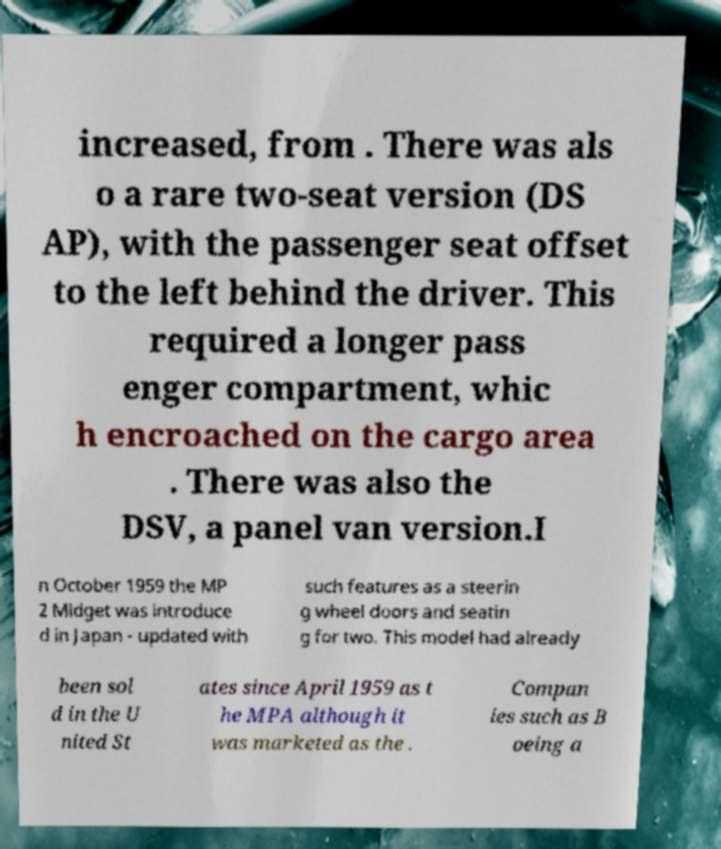Can you read and provide the text displayed in the image?This photo seems to have some interesting text. Can you extract and type it out for me? increased, from . There was als o a rare two-seat version (DS AP), with the passenger seat offset to the left behind the driver. This required a longer pass enger compartment, whic h encroached on the cargo area . There was also the DSV, a panel van version.I n October 1959 the MP 2 Midget was introduce d in Japan - updated with such features as a steerin g wheel doors and seatin g for two. This model had already been sol d in the U nited St ates since April 1959 as t he MPA although it was marketed as the . Compan ies such as B oeing a 